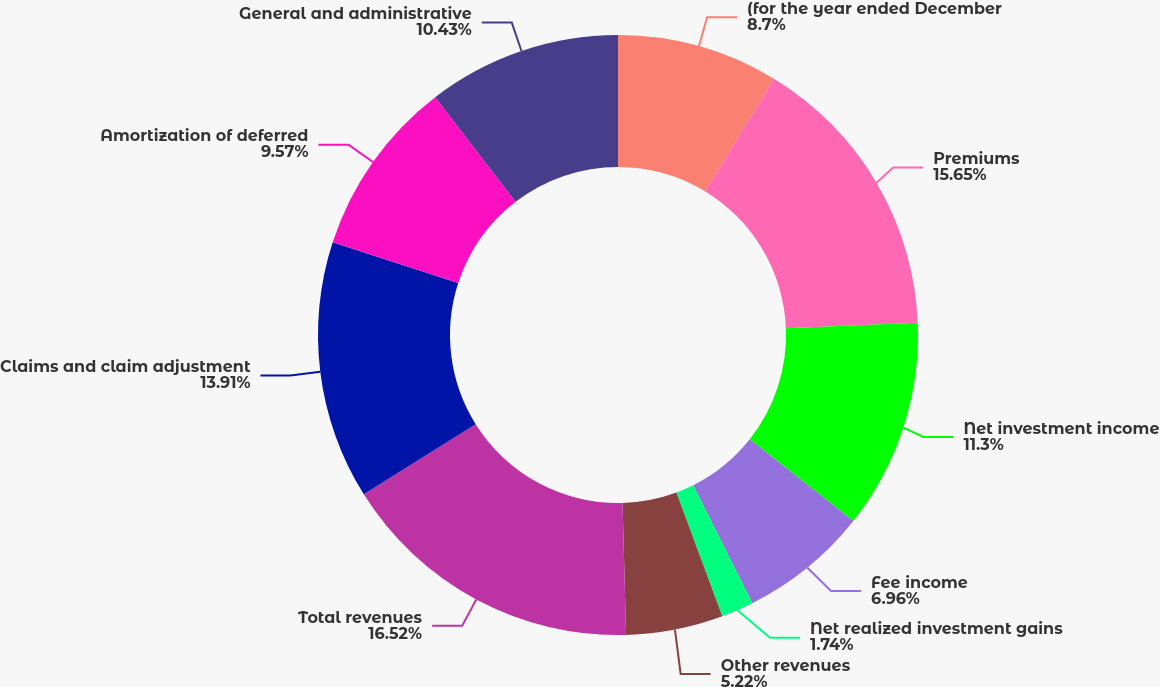Convert chart. <chart><loc_0><loc_0><loc_500><loc_500><pie_chart><fcel>(for the year ended December<fcel>Premiums<fcel>Net investment income<fcel>Fee income<fcel>Net realized investment gains<fcel>Other revenues<fcel>Total revenues<fcel>Claims and claim adjustment<fcel>Amortization of deferred<fcel>General and administrative<nl><fcel>8.7%<fcel>15.65%<fcel>11.3%<fcel>6.96%<fcel>1.74%<fcel>5.22%<fcel>16.52%<fcel>13.91%<fcel>9.57%<fcel>10.43%<nl></chart> 